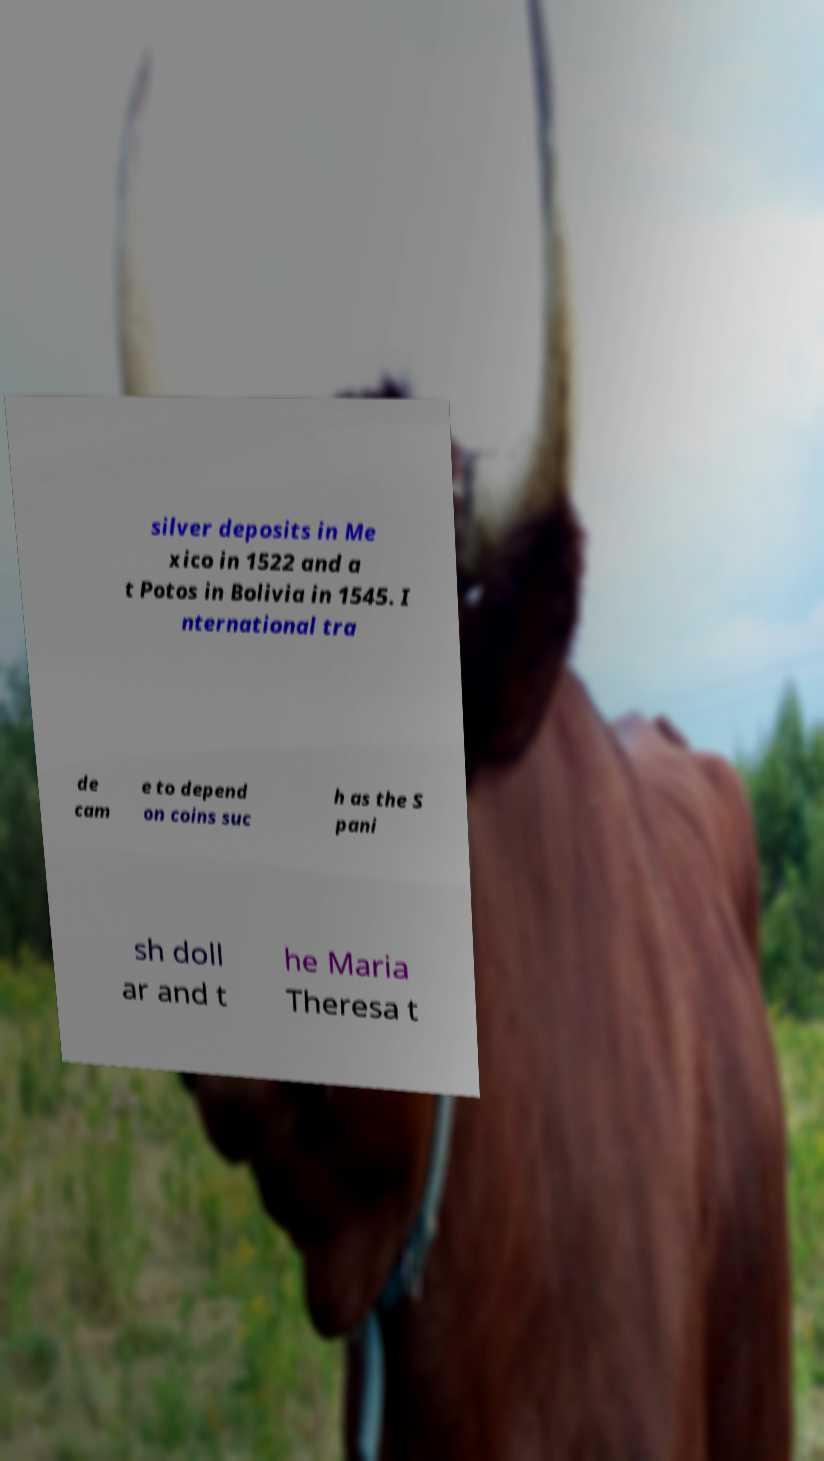Please read and relay the text visible in this image. What does it say? silver deposits in Me xico in 1522 and a t Potos in Bolivia in 1545. I nternational tra de cam e to depend on coins suc h as the S pani sh doll ar and t he Maria Theresa t 